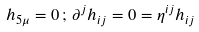Convert formula to latex. <formula><loc_0><loc_0><loc_500><loc_500>h _ { 5 \mu } = 0 \, ; \, \partial ^ { j } h _ { i j } = 0 = \eta ^ { i j } h _ { i j }</formula> 